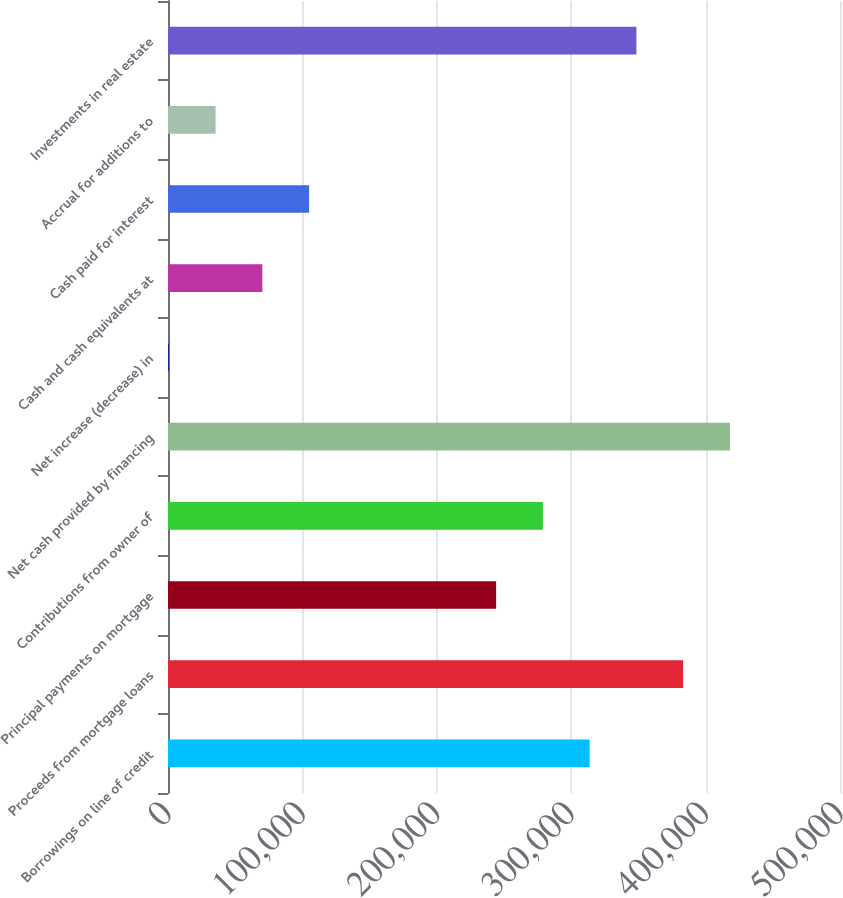<chart> <loc_0><loc_0><loc_500><loc_500><bar_chart><fcel>Borrowings on line of credit<fcel>Proceeds from mortgage loans<fcel>Principal payments on mortgage<fcel>Contributions from owner of<fcel>Net cash provided by financing<fcel>Net increase (decrease) in<fcel>Cash and cash equivalents at<fcel>Cash paid for interest<fcel>Accrual for additions to<fcel>Investments in real estate<nl><fcel>313718<fcel>383296<fcel>244140<fcel>278929<fcel>418085<fcel>617<fcel>70195<fcel>104984<fcel>35406<fcel>348507<nl></chart> 